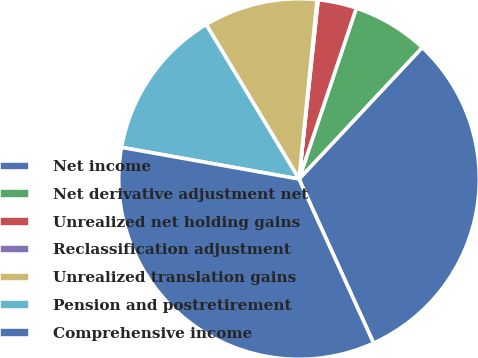Convert chart to OTSL. <chart><loc_0><loc_0><loc_500><loc_500><pie_chart><fcel>Net income<fcel>Net derivative adjustment net<fcel>Unrealized net holding gains<fcel>Reclassification adjustment<fcel>Unrealized translation gains<fcel>Pension and postretirement<fcel>Comprehensive income<nl><fcel>31.23%<fcel>6.83%<fcel>3.46%<fcel>0.09%<fcel>10.21%<fcel>13.58%<fcel>34.6%<nl></chart> 